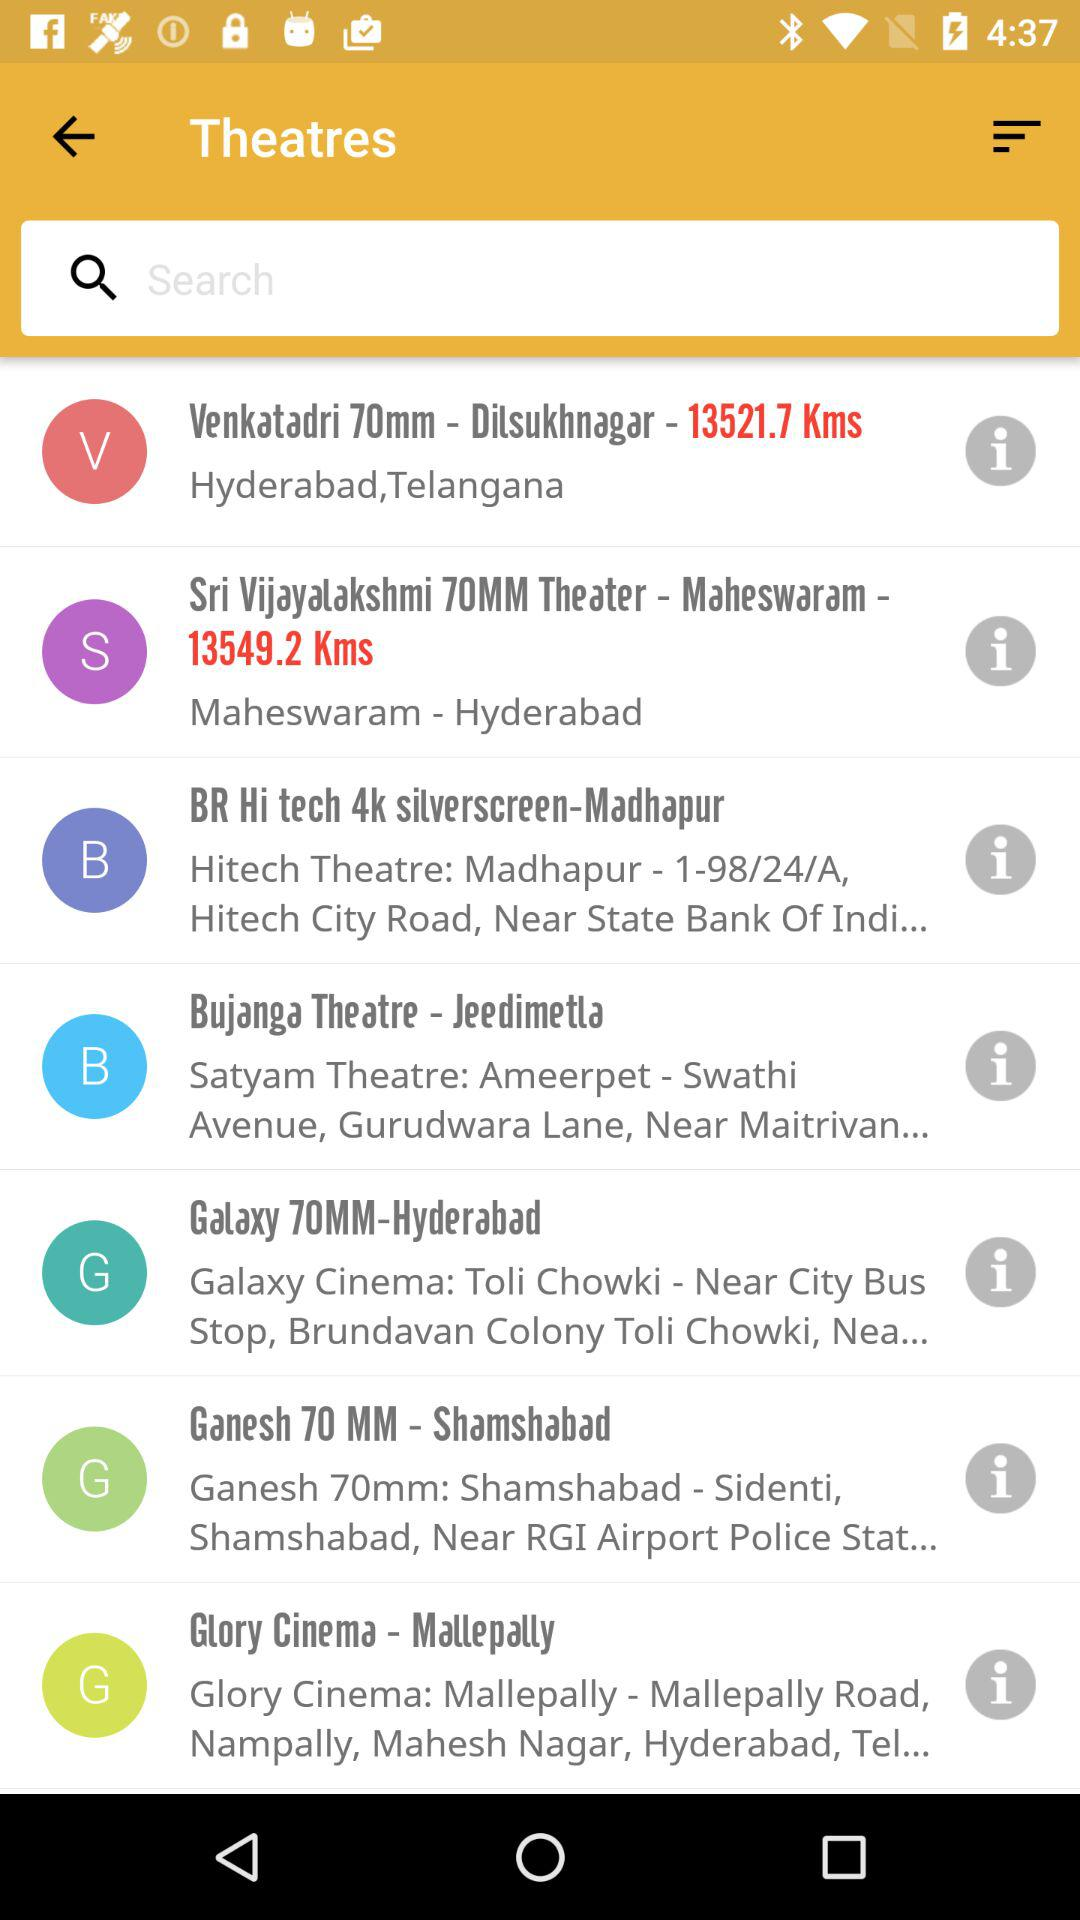What is the current location of "Glory Cinema - Malleplly"? The location is "Mallepally Road, Nampally, Mahesh Nagar, Hyderabad, Tel...". 